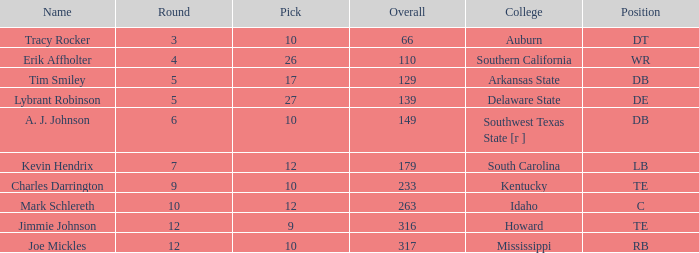What is the average Pick, when Name is "Lybrant Robinson", and when Overall is less than 139? None. 